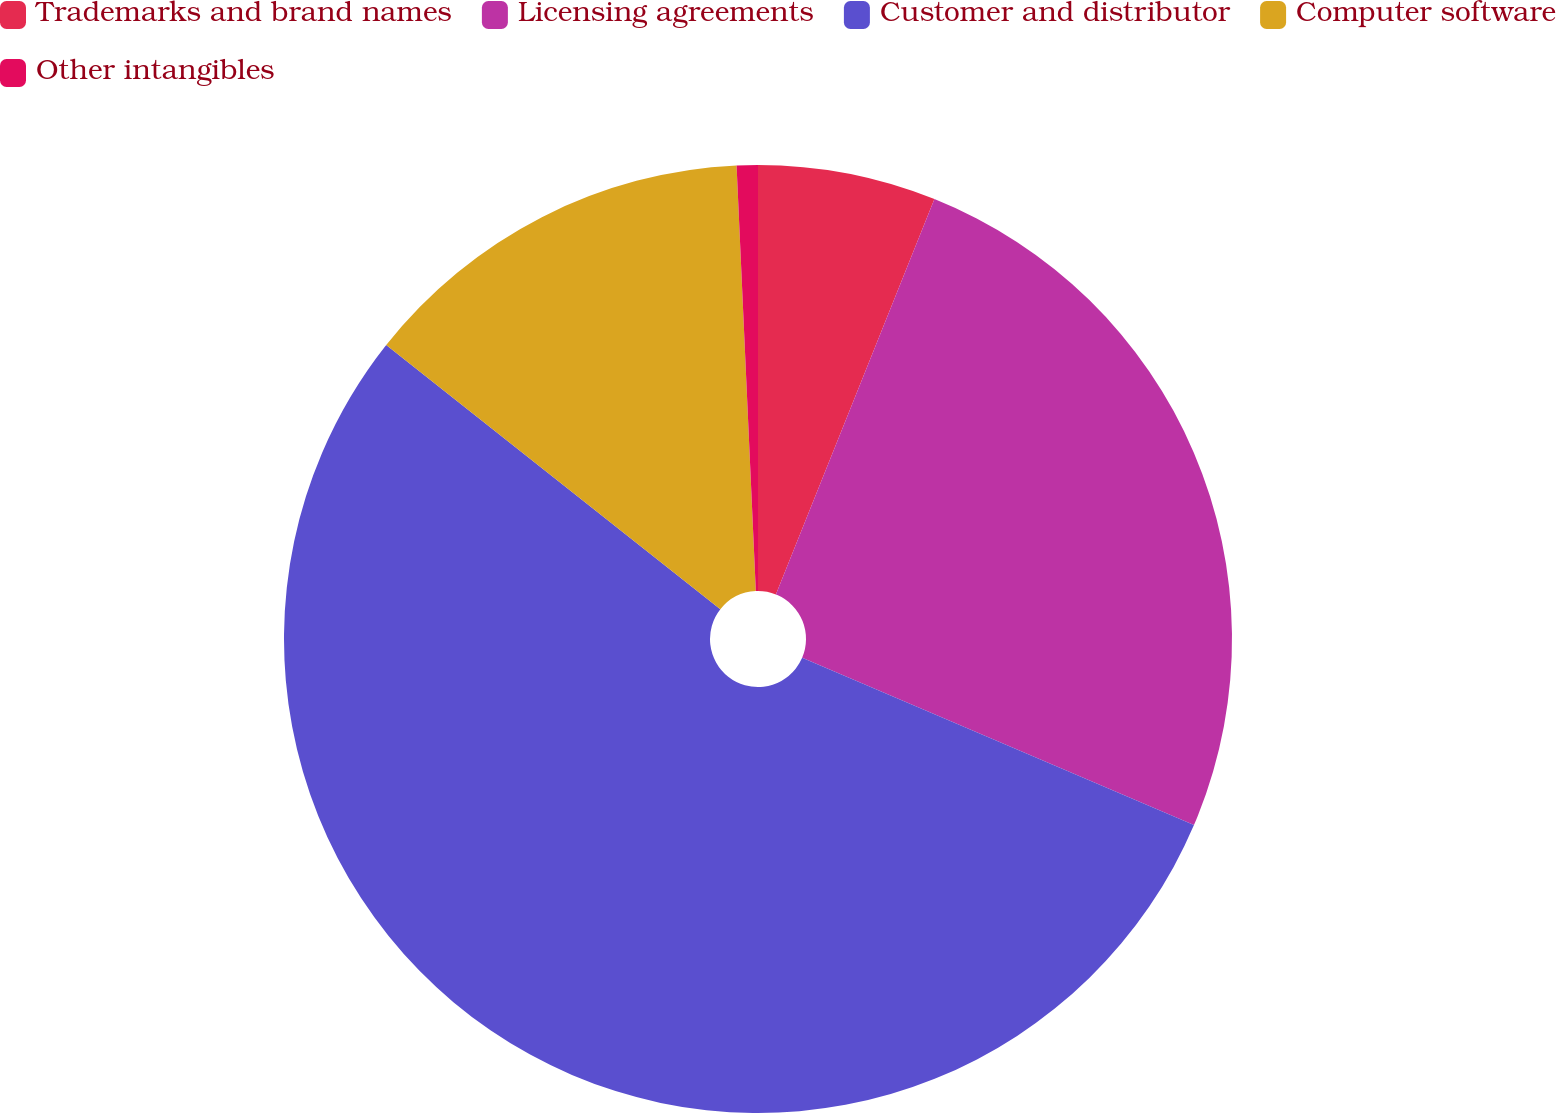Convert chart. <chart><loc_0><loc_0><loc_500><loc_500><pie_chart><fcel>Trademarks and brand names<fcel>Licensing agreements<fcel>Customer and distributor<fcel>Computer software<fcel>Other intangibles<nl><fcel>6.07%<fcel>25.35%<fcel>54.23%<fcel>13.63%<fcel>0.72%<nl></chart> 